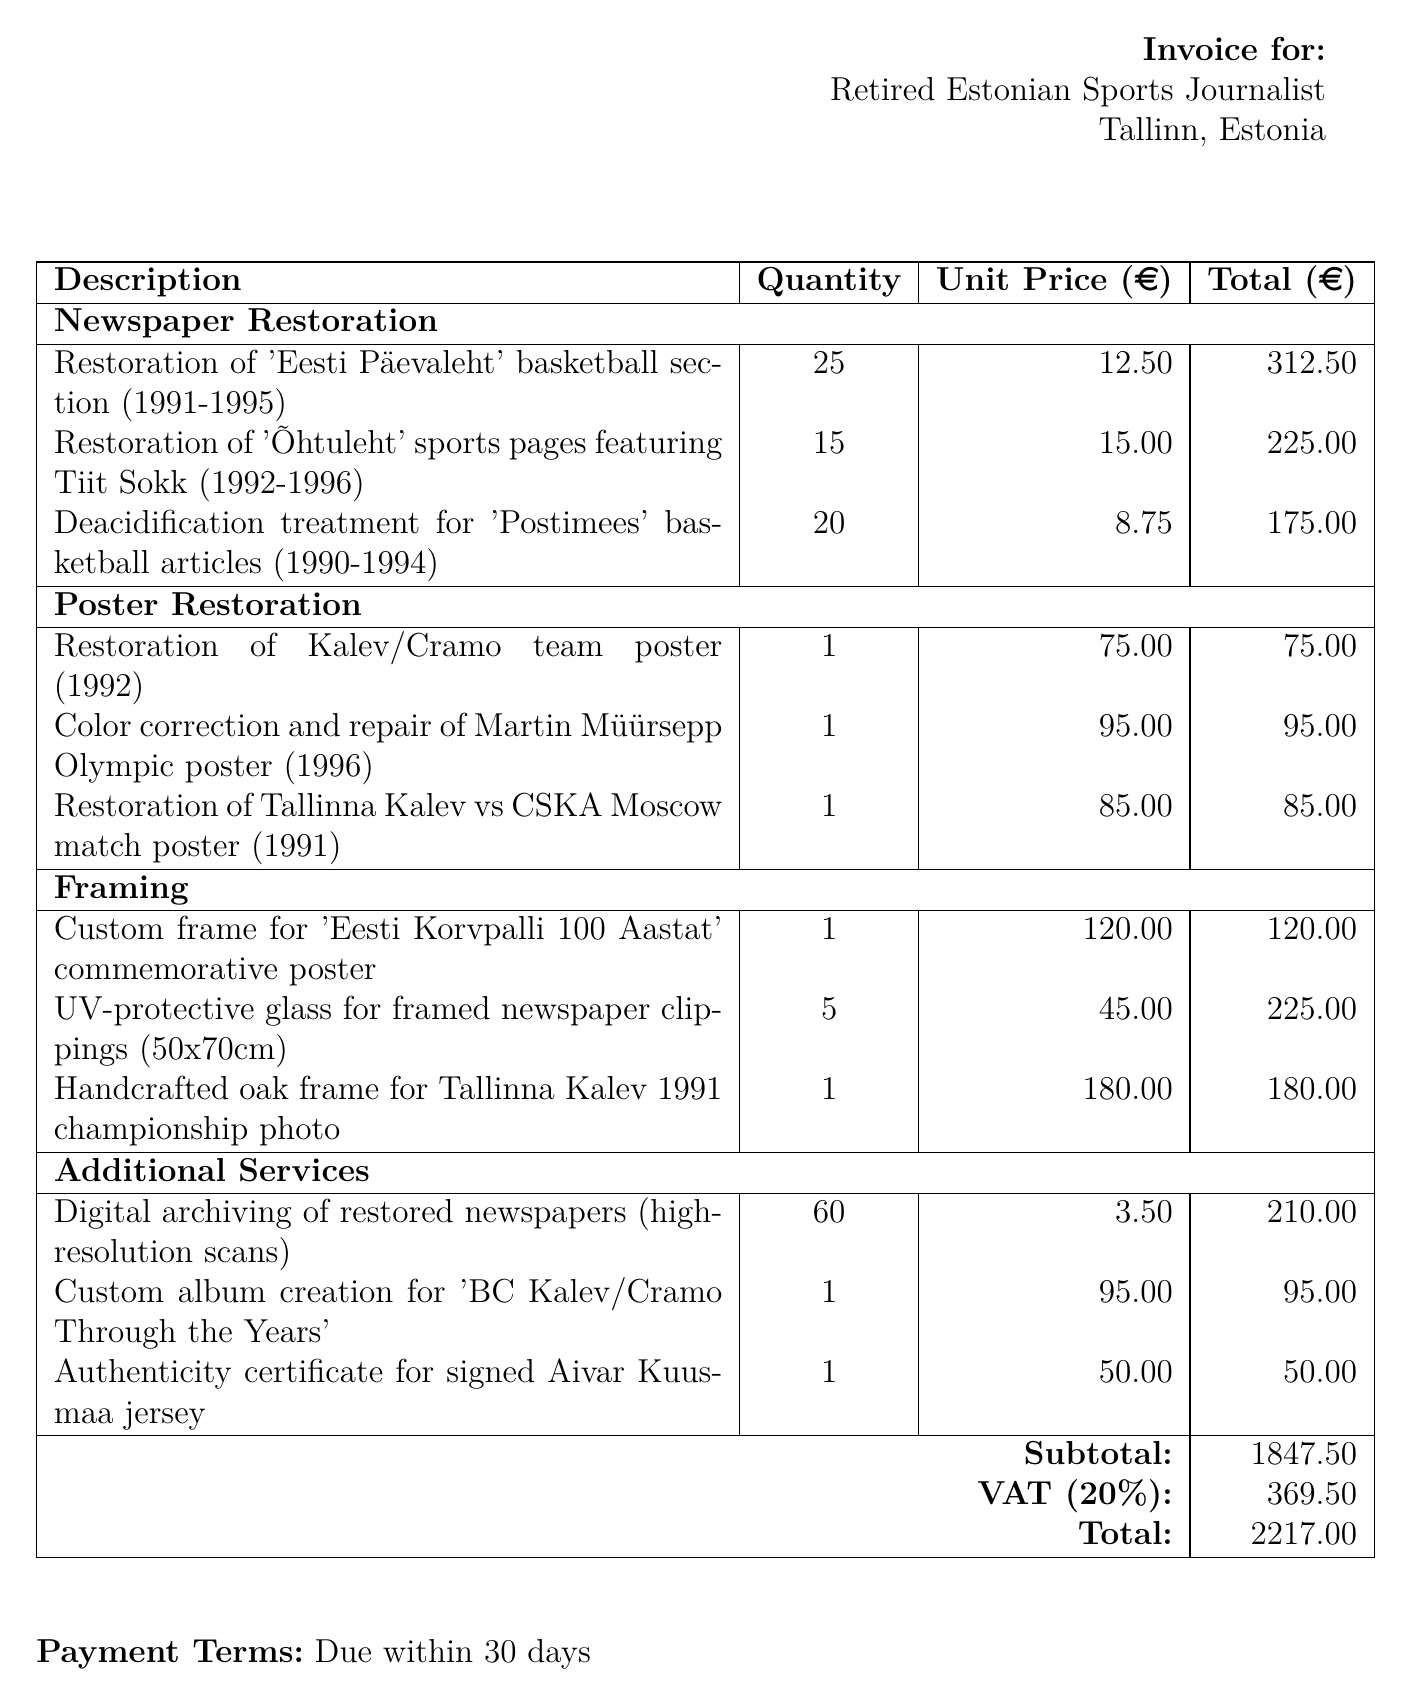What is the subtotal? The subtotal is the total of all costs before VAT is added. It is listed clearly in the document.
Answer: 1847.50 What service involves restoration of 'Eesti Päevaleht'? The document specifies different categories of restoration services, including one for 'Eesti Päevaleht'.
Answer: Newspaper Restoration How many posters were restored? The total quantity from the poster restoration section gives insight into the amount handled.
Answer: 3 What is the unit price of the handmade oak frame? The price for one handcrafted oak frame for a specific photo is provided in the framing section of the invoice.
Answer: 180.00 What is the total amount due? This is the completed total for all services, including VAT, at the end of the invoice.
Answer: 2217.00 Who performed the restoration work? The document notes the responsible entity for performing the restoration work, highlighting its credentials.
Answer: Estonian Sports Museum How many units of digital archiving were requested? The invoice details how many high-resolution scans were commissioned under additional services.
Answer: 60 What is the VAT rate applied? The VAT percentage applied to the subtotal is clearly stated in the document.
Answer: 20% What payment term is specified in the invoice? The document outlines when payment is expected from the recipient, detailing the payment duration.
Answer: Due within 30 days 